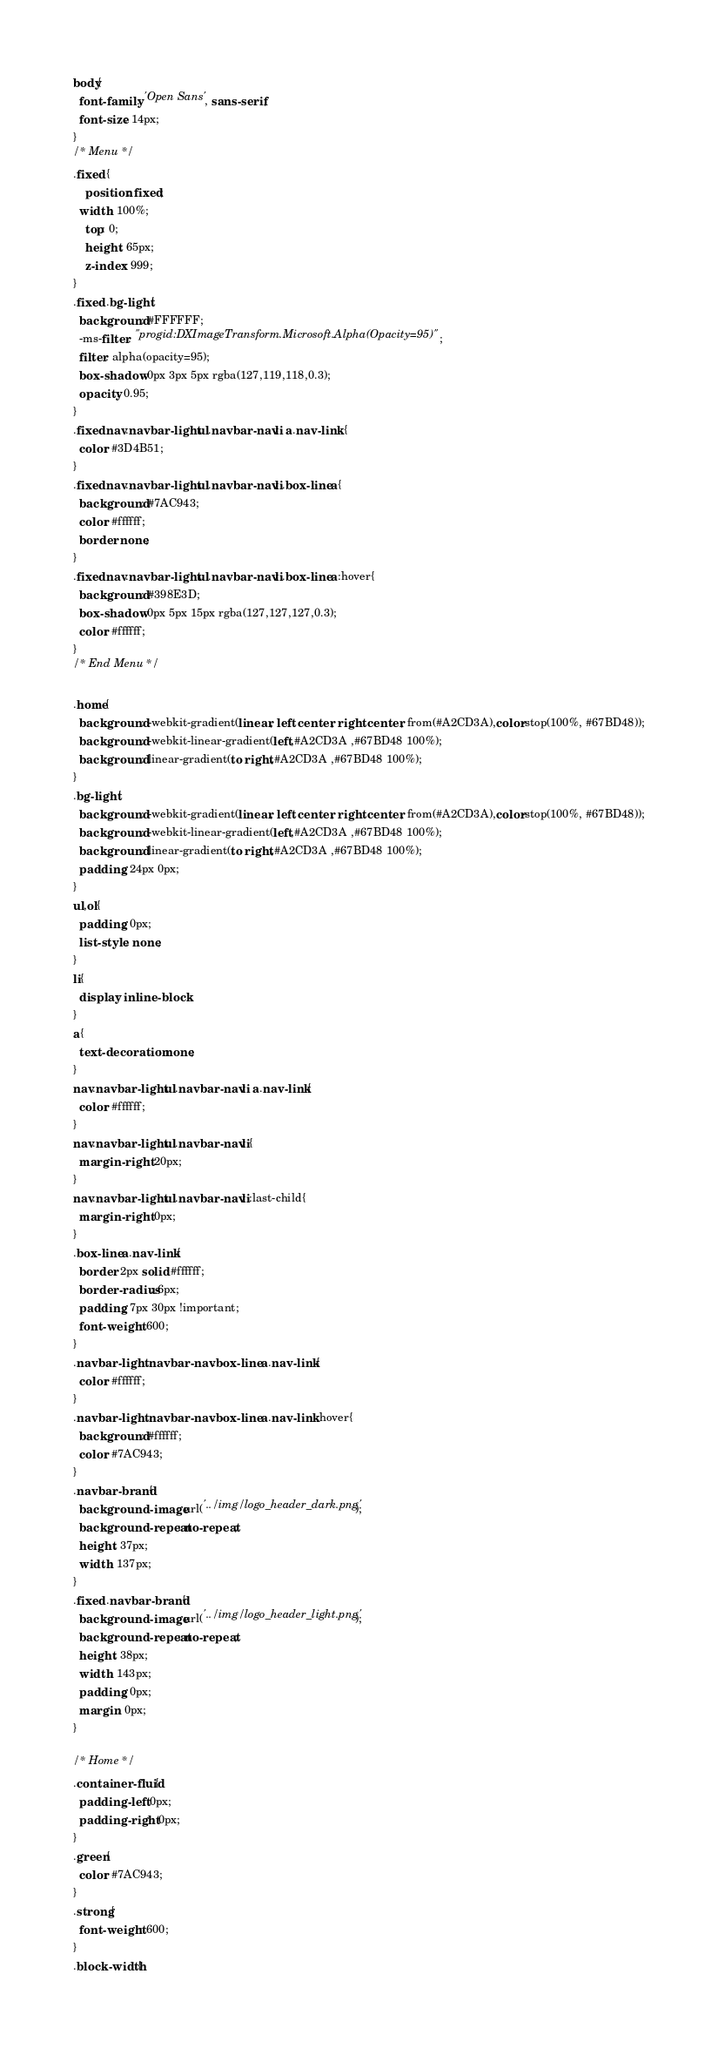<code> <loc_0><loc_0><loc_500><loc_500><_CSS_>body{
  font-family: 'Open Sans', sans-serif;
  font-size: 14px;
}
/* Menu */
.fixed {
	position: fixed;
  width: 100%;
	top: 0;
	height: 65px;
	z-index: 999;
}
.fixed .bg-light{
  background: #FFFFFF;
  -ms-filter: "progid:DXImageTransform.Microsoft.Alpha(Opacity=95)";
  filter: alpha(opacity=95);
  box-shadow: 0px 3px 5px rgba(127,119,118,0.3);
  opacity: 0.95;
}
.fixed nav.navbar-light ul.navbar-nav li a.nav-link {
  color: #3D4B51;
}
.fixed nav.navbar-light ul.navbar-nav li.box-line a{
  background: #7AC943;
  color: #ffffff;
  border: none;
}
.fixed nav.navbar-light ul.navbar-nav li.box-line a:hover{
  background: #398E3D;
  box-shadow: 0px 5px 15px rgba(127,127,127,0.3);
  color: #ffffff;
}
/* End Menu */

.home{
  background: -webkit-gradient(linear, left center, right center, from(#A2CD3A),color-stop(100%, #67BD48));
  background: -webkit-linear-gradient(left,#A2CD3A ,#67BD48 100%);
  background: linear-gradient(to right,#A2CD3A ,#67BD48 100%);
}
.bg-light{
  background: -webkit-gradient(linear, left center, right center, from(#A2CD3A),color-stop(100%, #67BD48));
  background: -webkit-linear-gradient(left,#A2CD3A ,#67BD48 100%);
  background: linear-gradient(to right,#A2CD3A ,#67BD48 100%);
  padding: 24px 0px;
}
ul,ol{
  padding: 0px;
  list-style: none;
}
li{
  display: inline-block
}
a{
  text-decoration: none;
}
nav.navbar-light ul.navbar-nav li a.nav-link{
  color: #ffffff;
}
nav.navbar-light ul.navbar-nav li{
  margin-right: 20px;
}
nav.navbar-light ul.navbar-nav li:last-child{
  margin-right: 0px;
}
.box-line a.nav-link{
  border: 2px solid #ffffff;
  border-radius: 6px;
  padding: 7px 30px !important;
  font-weight: 600;
}
.navbar-light .navbar-nav .box-line a.nav-link{
  color: #ffffff;
}
.navbar-light .navbar-nav .box-line a.nav-link:hover{
  background: #ffffff;
  color: #7AC943;
}
.navbar-brand{
  background-image: url('../img/logo_header_dark.png');
  background-repeat: no-repeat;
  height: 37px;
  width: 137px;
}
.fixed .navbar-brand{
  background-image: url('../img/logo_header_light.png');
  background-repeat: no-repeat;
  height: 38px;
  width: 143px;
  padding: 0px;
  margin: 0px;
}

/* Home */
.container-fluid{
  padding-left: 0px;
  padding-right: 0px;
}
.green{
  color: #7AC943;
}
.strong{
  font-weight: 600;
}
.block-width{</code> 